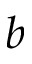Convert formula to latex. <formula><loc_0><loc_0><loc_500><loc_500>b</formula> 